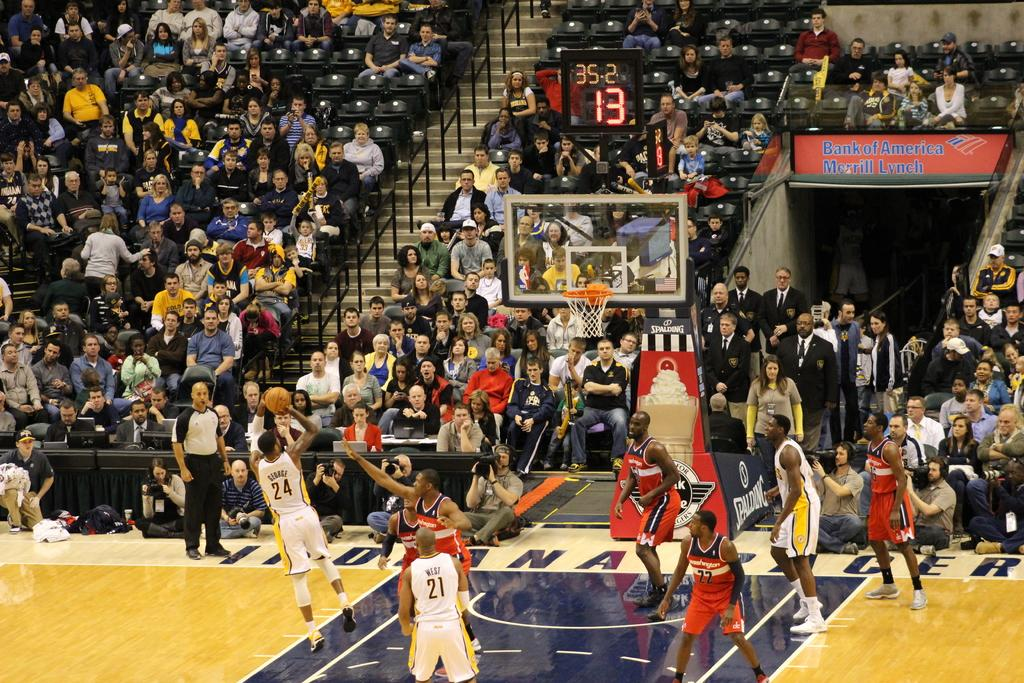Provide a one-sentence caption for the provided image. A basketball player shoots a fade away with 13 seconds left on the shot clock and 35 seconds left in the half. 